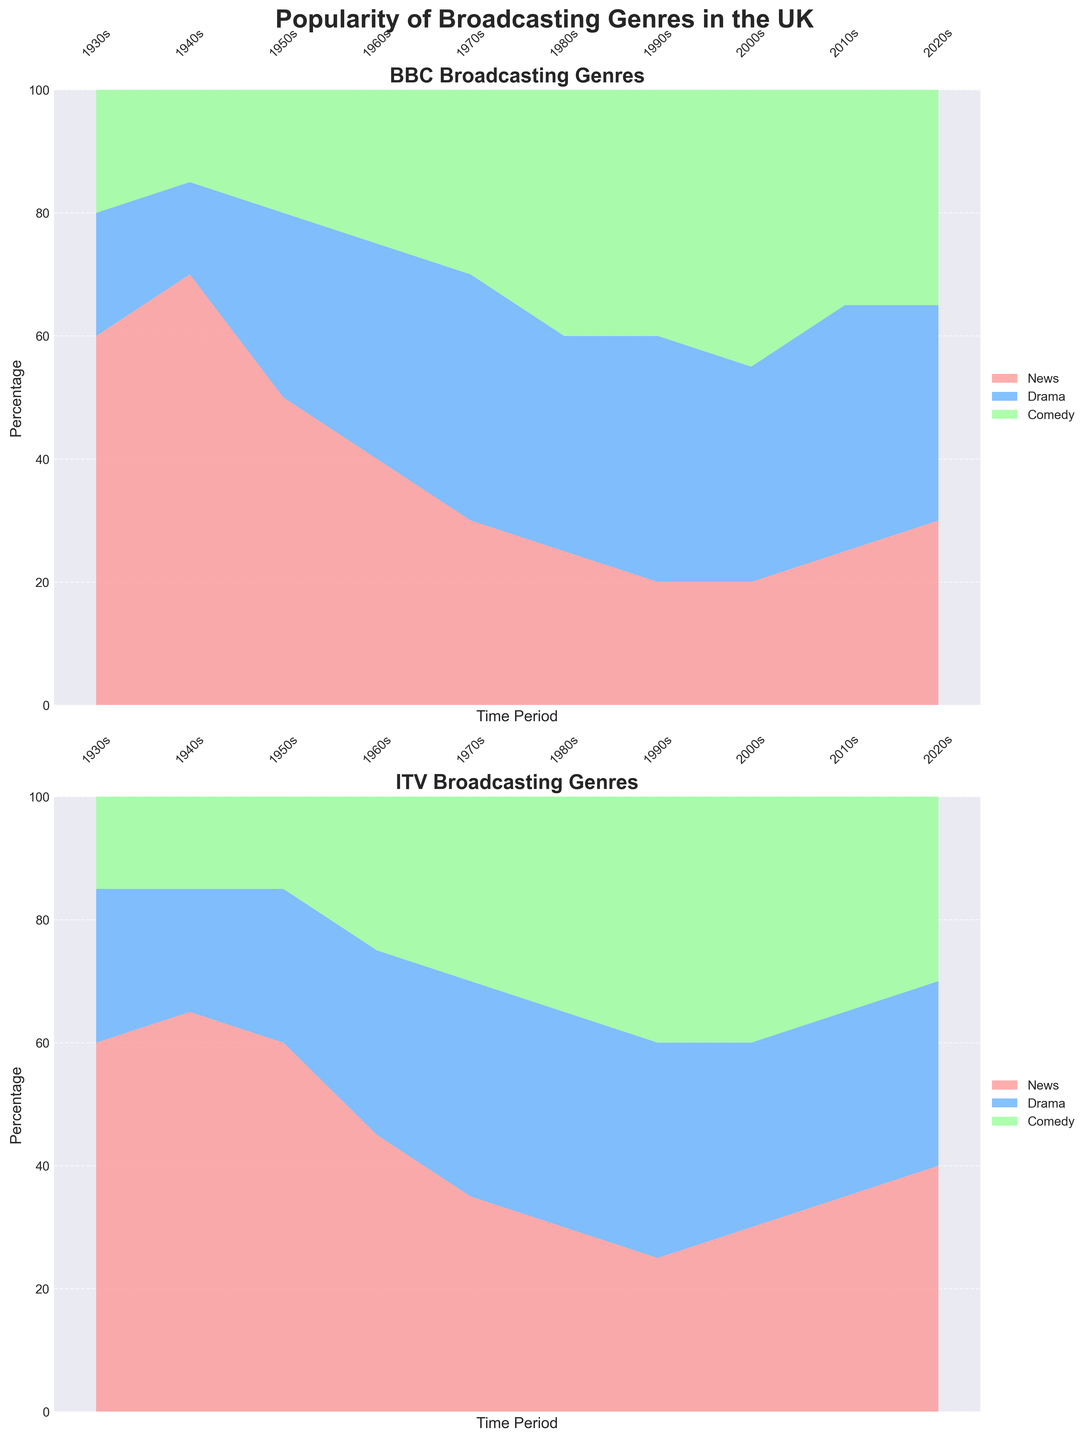what is the title of the figure? The title is positioned at the top of the figure and states the overall theme of the visual representation.
Answer: Popularity of Broadcasting Genres in the UK Which broadcasting genre consistently dominates in the 1930s for both BBC and ITV? By observing the stack plots for both networks in the 1930s, the segment with the highest area in both plots represents the most popular genre.
Answer: News How did the popularity of Comedy change for the BBC from the 1930s to the 1980s? Examine the area representing Comedy in the BBC plot from the 1930s to the 1980s and note the percentage at each time point: 20% (1930s), 15% (1940s), 20% (1950s), 25% (1960s), 30% (1970s), 40% (1980s).
Answer: It increased by 20% Between the two networks, which one saw a decline in the popularity of News from the 1940s to the 1990s? Look at the percentage of News in both the BBC and ITV plots from the 1940s to the 1990s. BBC dropped from 70% to 20%, while ITV dropped from 65% to 25%.
Answer: BBC In the 2010s, which genre shared the exact same percentage on both BBC and ITV? Locate the 2010s data on both plots and identify the genre areas that have matching percentages.
Answer: Comedy How did Drama popularity for ITV change from the 1960s to the 2020s? Trace the area representing Drama in the ITV plot across these decades: 30% (1960s), 30% (2020s).
Answer: It remained the same By comparing the 1950s and 1980s data for BBC, which genre experienced the largest percentage increase? Look at the percentage change for each genre between these periods: News (50% to 25%), Drama (30% to 35%), Comedy (20% to 40%).
Answer: Comedy Which network had a more stable trend in the popularity of the Drama genre over time? Compare the Drama areas for both BBC and ITV across the entire time period 1930s to 2020s. ITV shows less fluctuation compared to BBC.
Answer: ITV What is the percentage of Comedy in the 2000s for ITV? Locate the 2000s data on the ITV plot and examine the height of the Comedy area.
Answer: 40% 